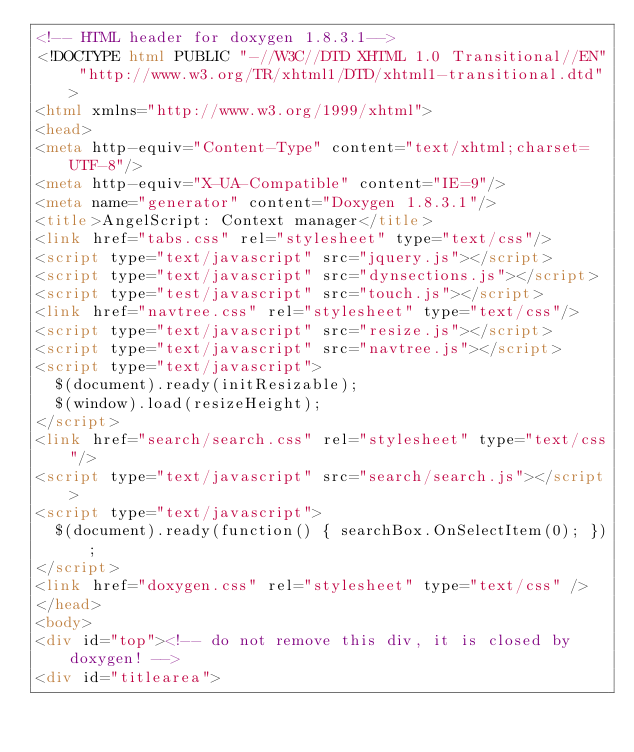Convert code to text. <code><loc_0><loc_0><loc_500><loc_500><_HTML_><!-- HTML header for doxygen 1.8.3.1-->
<!DOCTYPE html PUBLIC "-//W3C//DTD XHTML 1.0 Transitional//EN" "http://www.w3.org/TR/xhtml1/DTD/xhtml1-transitional.dtd">
<html xmlns="http://www.w3.org/1999/xhtml">
<head>
<meta http-equiv="Content-Type" content="text/xhtml;charset=UTF-8"/>
<meta http-equiv="X-UA-Compatible" content="IE=9"/>
<meta name="generator" content="Doxygen 1.8.3.1"/>
<title>AngelScript: Context manager</title>
<link href="tabs.css" rel="stylesheet" type="text/css"/>
<script type="text/javascript" src="jquery.js"></script>
<script type="text/javascript" src="dynsections.js"></script>
<script type="test/javascript" src="touch.js"></script>
<link href="navtree.css" rel="stylesheet" type="text/css"/>
<script type="text/javascript" src="resize.js"></script>
<script type="text/javascript" src="navtree.js"></script>
<script type="text/javascript">
  $(document).ready(initResizable);
  $(window).load(resizeHeight);
</script>
<link href="search/search.css" rel="stylesheet" type="text/css"/>
<script type="text/javascript" src="search/search.js"></script>
<script type="text/javascript">
  $(document).ready(function() { searchBox.OnSelectItem(0); });
</script>
<link href="doxygen.css" rel="stylesheet" type="text/css" />
</head>
<body>
<div id="top"><!-- do not remove this div, it is closed by doxygen! -->
<div id="titlearea"></code> 